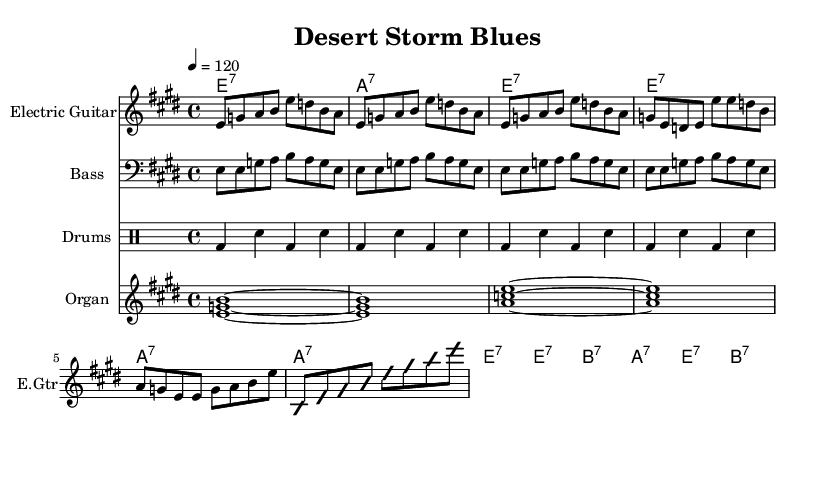What is the key signature of this music? The key signature is E major, which has four sharps (F#, C#, G#, D#). This can be identified by looking at the key signature indicated at the beginning of the staff.
Answer: E major What is the time signature of this music? The time signature is 4/4, which is noted at the beginning of the score. This means there are four beats in each measure and the quarter note gets one beat.
Answer: 4/4 What is the tempo marking of this piece? The tempo marking is 120 beats per minute, indicated in the music as "4 = 120," which shows that the quarter note should be played at this speed.
Answer: 120 How many measures are in the verse? The verse consists of 8 measures, as counted from the repeated structure within the section labeled as the verse and includes the measures that follow.
Answer: 8 What chords are used in the chorus? The chorus features the chords E7, B7, and A7, which appear in the chord names section of the music, and contextually follow the structure of the chorus.
Answer: E7, B7, A7 What instrument is playing the melody? The melody is played by the Electric Guitar, as indicated at the beginning of the respective staff that is set for the electric guitar part.
Answer: Electric Guitar What is the main theme of the lyrics suggested in the music? The main theme of the music suggests a military and patriotic vibe, inferred from the title "Desert Storm Blues" and the general style of electric blues, which often conveys themes of struggle and resilience.
Answer: Military and patriotic 